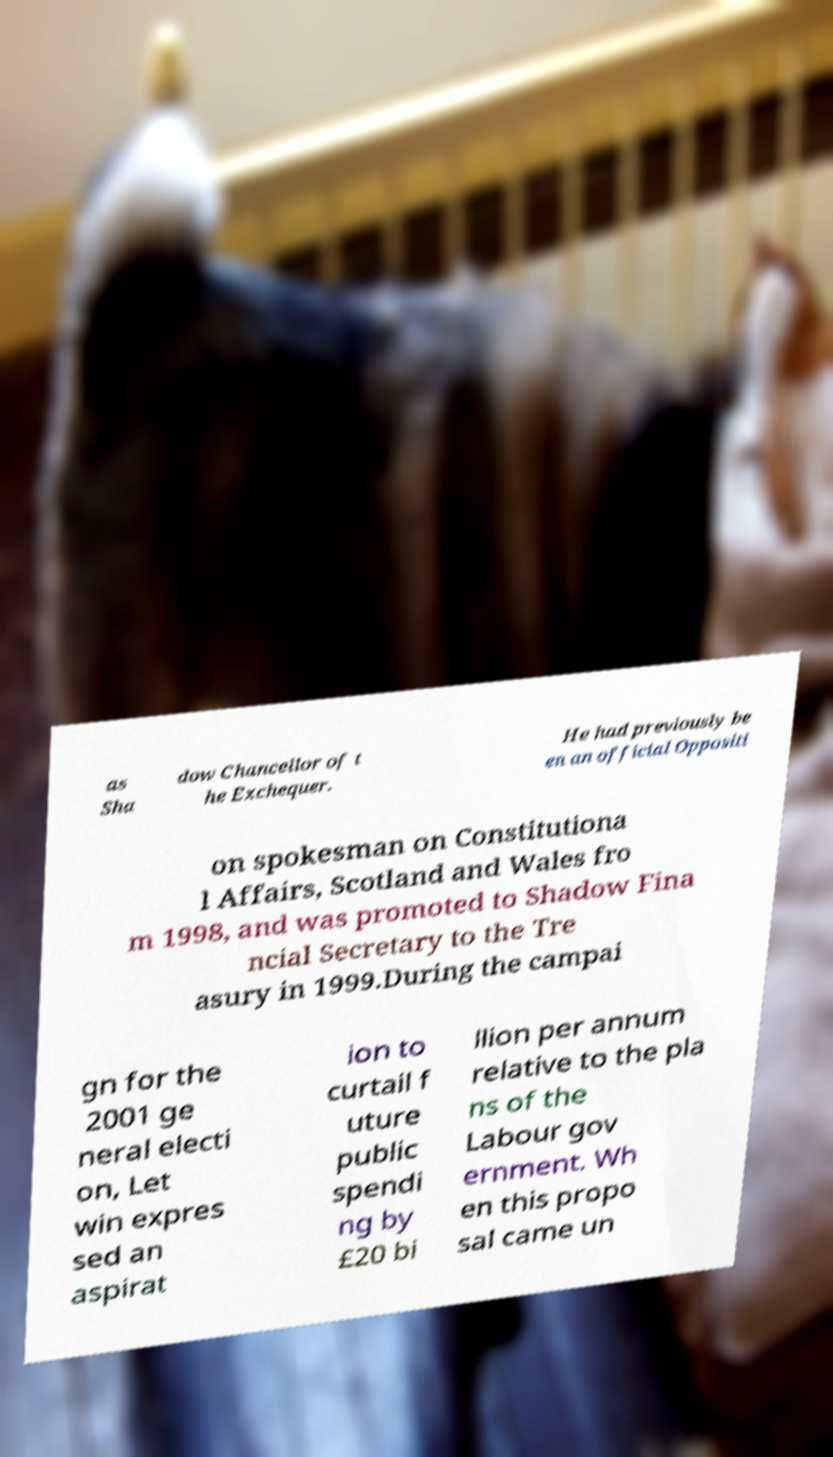Could you extract and type out the text from this image? as Sha dow Chancellor of t he Exchequer. He had previously be en an official Oppositi on spokesman on Constitutiona l Affairs, Scotland and Wales fro m 1998, and was promoted to Shadow Fina ncial Secretary to the Tre asury in 1999.During the campai gn for the 2001 ge neral electi on, Let win expres sed an aspirat ion to curtail f uture public spendi ng by £20 bi llion per annum relative to the pla ns of the Labour gov ernment. Wh en this propo sal came un 